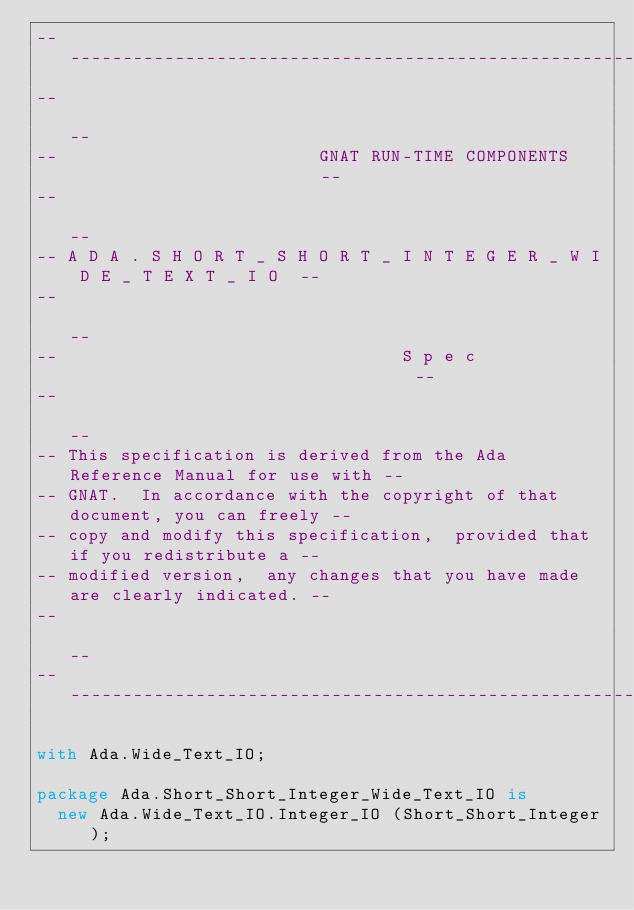Convert code to text. <code><loc_0><loc_0><loc_500><loc_500><_Ada_>------------------------------------------------------------------------------
--                                                                          --
--                         GNAT RUN-TIME COMPONENTS                         --
--                                                                          --
-- A D A . S H O R T _ S H O R T _ I N T E G E R _ W I D E _ T E X T _ I O  --
--                                                                          --
--                                 S p e c                                  --
--                                                                          --
-- This specification is derived from the Ada Reference Manual for use with --
-- GNAT.  In accordance with the copyright of that document, you can freely --
-- copy and modify this specification,  provided that if you redistribute a --
-- modified version,  any changes that you have made are clearly indicated. --
--                                                                          --
------------------------------------------------------------------------------

with Ada.Wide_Text_IO;

package Ada.Short_Short_Integer_Wide_Text_IO is
  new Ada.Wide_Text_IO.Integer_IO (Short_Short_Integer);
</code> 